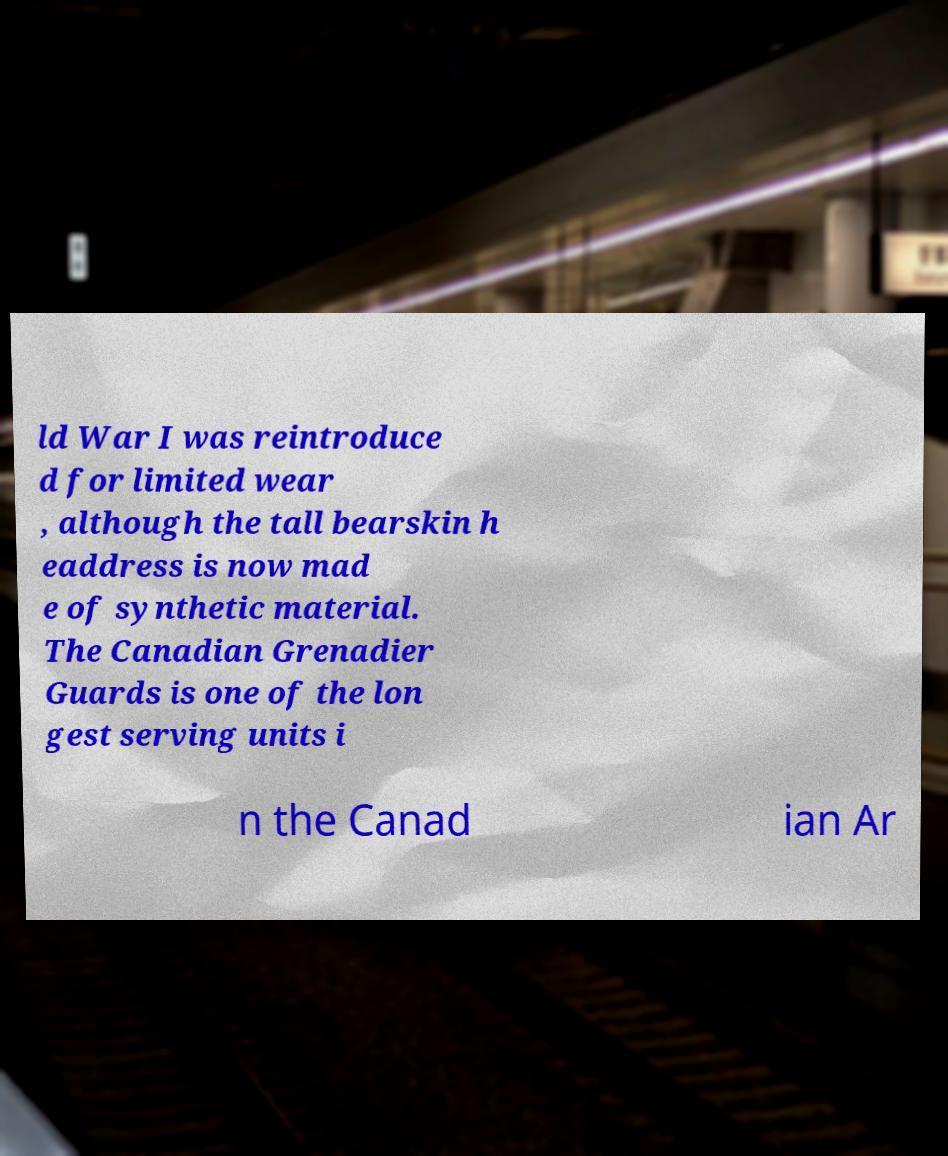I need the written content from this picture converted into text. Can you do that? ld War I was reintroduce d for limited wear , although the tall bearskin h eaddress is now mad e of synthetic material. The Canadian Grenadier Guards is one of the lon gest serving units i n the Canad ian Ar 